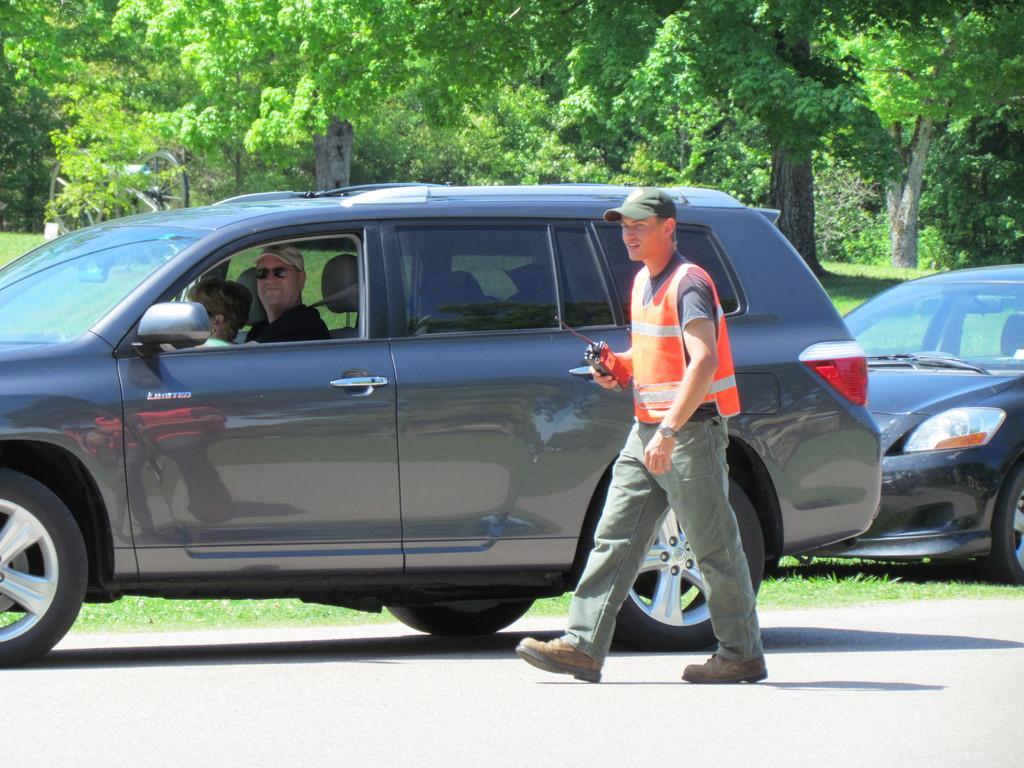Please provide a concise description of this image. This is an outside view. There is a person walking on the road. Just beside this this person there is a vehicle. On the right side of the image there is a car. In the background we can see trees. 